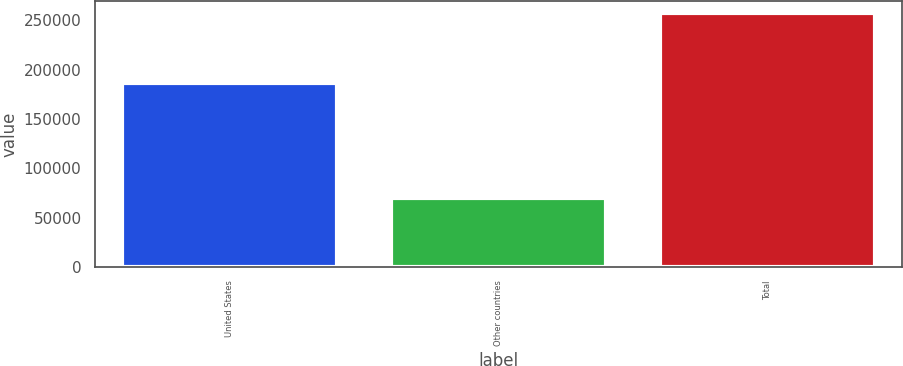Convert chart to OTSL. <chart><loc_0><loc_0><loc_500><loc_500><bar_chart><fcel>United States<fcel>Other countries<fcel>Total<nl><fcel>186854<fcel>70181<fcel>257035<nl></chart> 